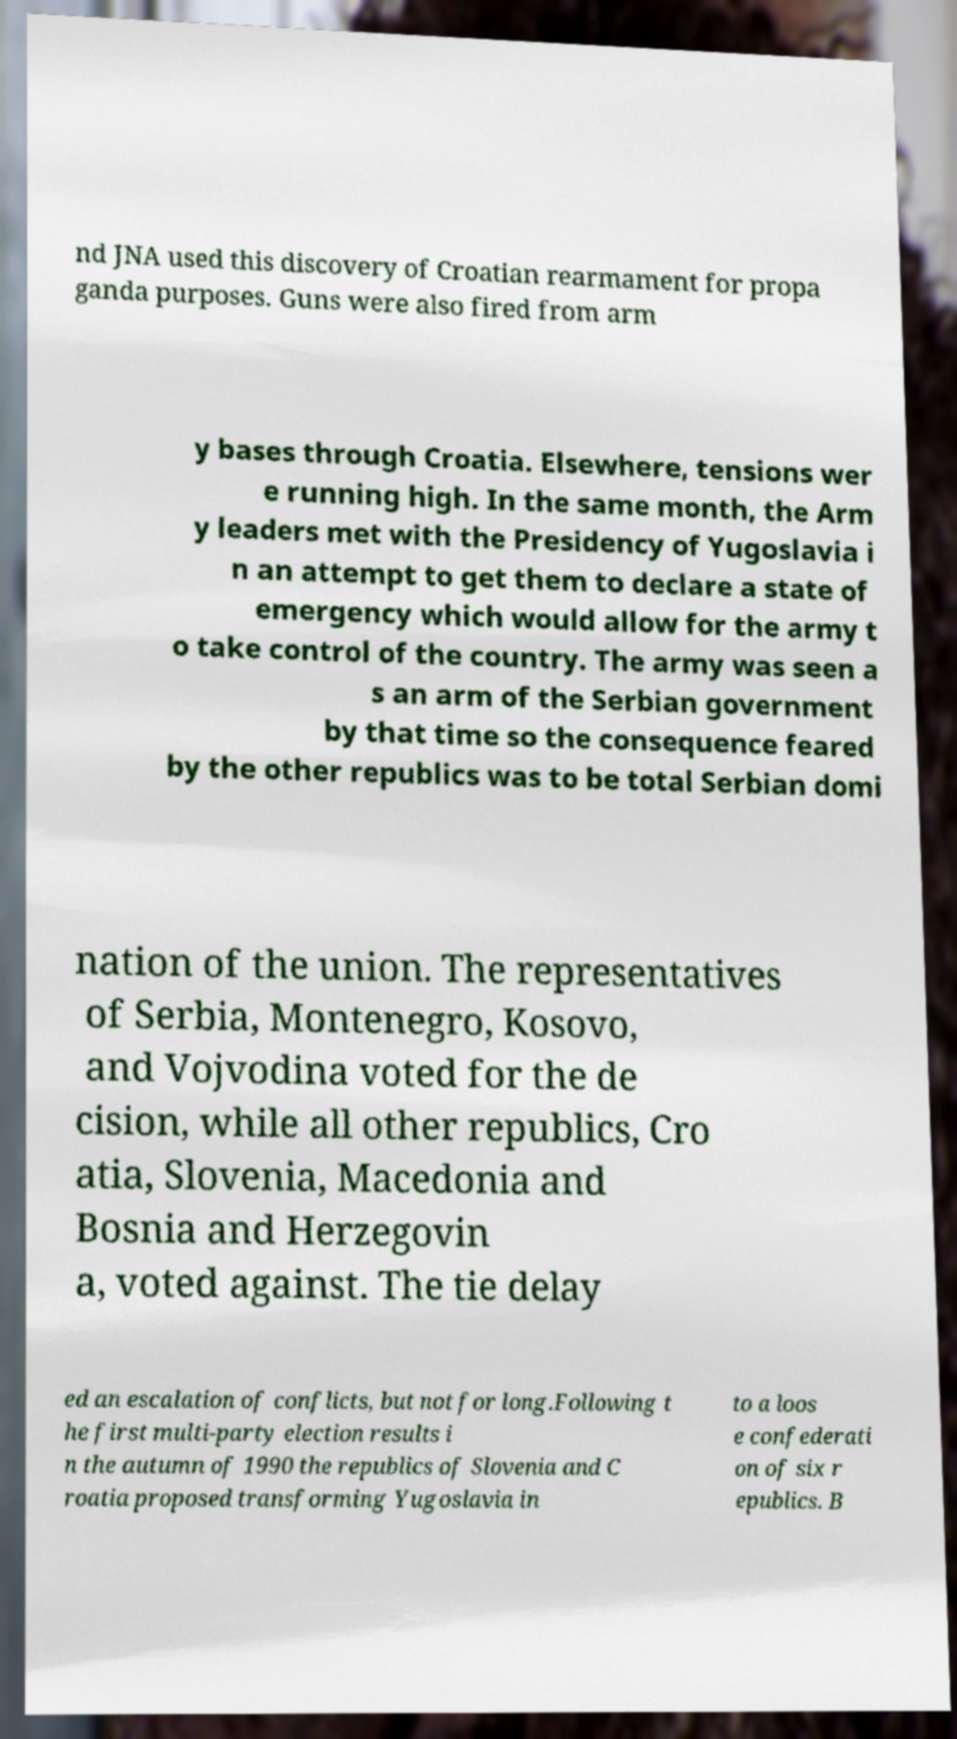Could you assist in decoding the text presented in this image and type it out clearly? nd JNA used this discovery of Croatian rearmament for propa ganda purposes. Guns were also fired from arm y bases through Croatia. Elsewhere, tensions wer e running high. In the same month, the Arm y leaders met with the Presidency of Yugoslavia i n an attempt to get them to declare a state of emergency which would allow for the army t o take control of the country. The army was seen a s an arm of the Serbian government by that time so the consequence feared by the other republics was to be total Serbian domi nation of the union. The representatives of Serbia, Montenegro, Kosovo, and Vojvodina voted for the de cision, while all other republics, Cro atia, Slovenia, Macedonia and Bosnia and Herzegovin a, voted against. The tie delay ed an escalation of conflicts, but not for long.Following t he first multi-party election results i n the autumn of 1990 the republics of Slovenia and C roatia proposed transforming Yugoslavia in to a loos e confederati on of six r epublics. B 